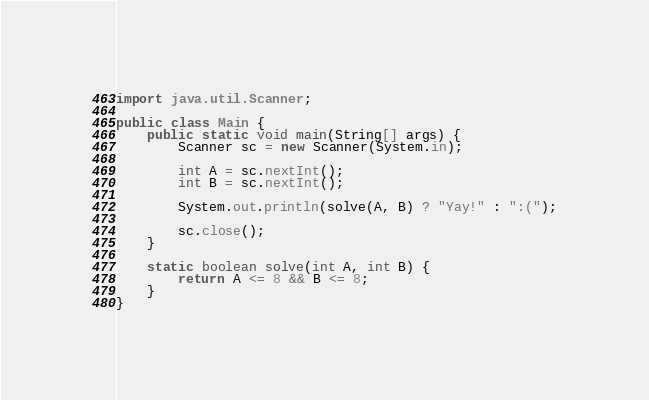Convert code to text. <code><loc_0><loc_0><loc_500><loc_500><_Java_>import java.util.Scanner;

public class Main {
    public static void main(String[] args) {
        Scanner sc = new Scanner(System.in);

        int A = sc.nextInt();
        int B = sc.nextInt();

        System.out.println(solve(A, B) ? "Yay!" : ":(");

        sc.close();
    }

    static boolean solve(int A, int B) {
        return A <= 8 && B <= 8;
    }
}</code> 